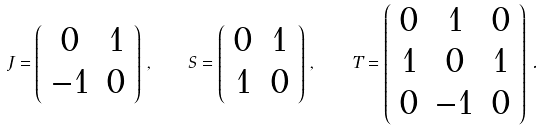<formula> <loc_0><loc_0><loc_500><loc_500>J = \left ( \begin{array} { c c } 0 & 1 \\ - 1 & 0 \end{array} \right ) \, , \quad S = \left ( \begin{array} { c c } 0 & 1 \\ 1 & 0 \end{array} \right ) \, , \quad T = \left ( \begin{array} { c c c } 0 & 1 & 0 \\ 1 & 0 & 1 \\ 0 & - 1 & 0 \\ \end{array} \right ) \, .</formula> 